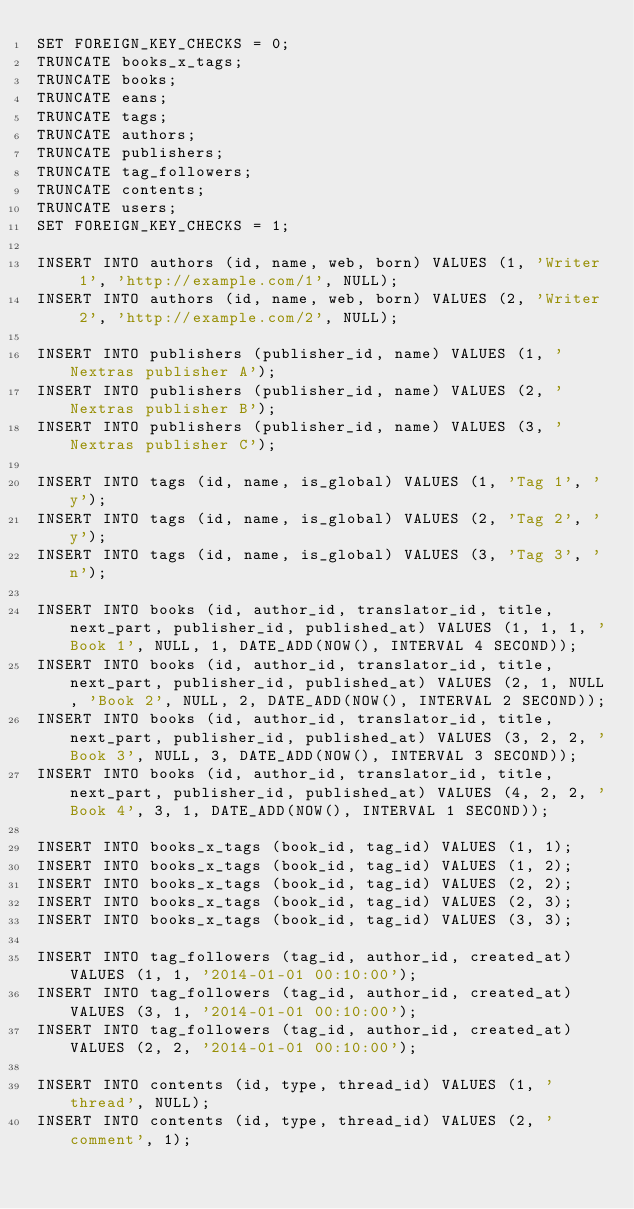Convert code to text. <code><loc_0><loc_0><loc_500><loc_500><_SQL_>SET FOREIGN_KEY_CHECKS = 0;
TRUNCATE books_x_tags;
TRUNCATE books;
TRUNCATE eans;
TRUNCATE tags;
TRUNCATE authors;
TRUNCATE publishers;
TRUNCATE tag_followers;
TRUNCATE contents;
TRUNCATE users;
SET FOREIGN_KEY_CHECKS = 1;

INSERT INTO authors (id, name, web, born) VALUES (1, 'Writer 1', 'http://example.com/1', NULL);
INSERT INTO authors (id, name, web, born) VALUES (2, 'Writer 2', 'http://example.com/2', NULL);

INSERT INTO publishers (publisher_id, name) VALUES (1, 'Nextras publisher A');
INSERT INTO publishers (publisher_id, name) VALUES (2, 'Nextras publisher B');
INSERT INTO publishers (publisher_id, name) VALUES (3, 'Nextras publisher C');

INSERT INTO tags (id, name, is_global) VALUES (1, 'Tag 1', 'y');
INSERT INTO tags (id, name, is_global) VALUES (2, 'Tag 2', 'y');
INSERT INTO tags (id, name, is_global) VALUES (3, 'Tag 3', 'n');

INSERT INTO books (id, author_id, translator_id, title, next_part, publisher_id, published_at) VALUES (1, 1, 1, 'Book 1', NULL, 1, DATE_ADD(NOW(), INTERVAL 4 SECOND));
INSERT INTO books (id, author_id, translator_id, title, next_part, publisher_id, published_at) VALUES (2, 1, NULL, 'Book 2', NULL, 2, DATE_ADD(NOW(), INTERVAL 2 SECOND));
INSERT INTO books (id, author_id, translator_id, title, next_part, publisher_id, published_at) VALUES (3, 2, 2, 'Book 3', NULL, 3, DATE_ADD(NOW(), INTERVAL 3 SECOND));
INSERT INTO books (id, author_id, translator_id, title, next_part, publisher_id, published_at) VALUES (4, 2, 2, 'Book 4', 3, 1, DATE_ADD(NOW(), INTERVAL 1 SECOND));

INSERT INTO books_x_tags (book_id, tag_id) VALUES (1, 1);
INSERT INTO books_x_tags (book_id, tag_id) VALUES (1, 2);
INSERT INTO books_x_tags (book_id, tag_id) VALUES (2, 2);
INSERT INTO books_x_tags (book_id, tag_id) VALUES (2, 3);
INSERT INTO books_x_tags (book_id, tag_id) VALUES (3, 3);

INSERT INTO tag_followers (tag_id, author_id, created_at) VALUES (1, 1, '2014-01-01 00:10:00');
INSERT INTO tag_followers (tag_id, author_id, created_at) VALUES (3, 1, '2014-01-01 00:10:00');
INSERT INTO tag_followers (tag_id, author_id, created_at) VALUES (2, 2, '2014-01-01 00:10:00');

INSERT INTO contents (id, type, thread_id) VALUES (1, 'thread', NULL);
INSERT INTO contents (id, type, thread_id) VALUES (2, 'comment', 1);
</code> 